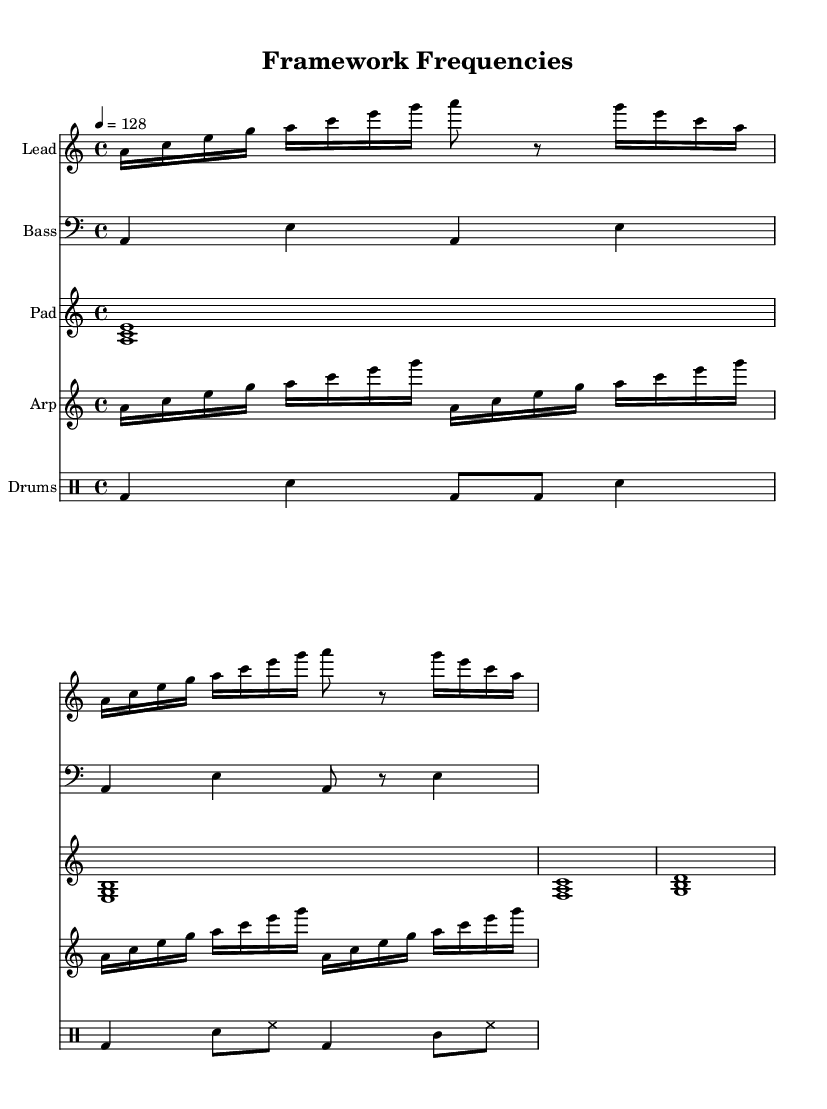What is the key signature of this music? The key signature is specified at the beginning of the global definitions section. It indicates that the piece is in A minor, which has no sharps or flats.
Answer: A minor What is the time signature of this track? The time signature is also set in the global definitions section of the code. It shows a 4/4 time signature, which is common in house music for its steady rhythm.
Answer: 4/4 What is the tempo of the piece? The tempo is defined in the global section, with a speed of 128 beats per minute, typical for progressive house tracks that maintain an energetic pace.
Answer: 128 How many voices are present in the lead section? The lead section has a pattern that repeats many notes and includes distinct pitches. Analyzing the notes played together, there is mainly one voice in the lead synth.
Answer: 1 Which instrument plays the bass line? The instrument for the bass line is labeled in the score following its respective staff. It has a specific instrument name listed, which indicates that the bass synth is used.
Answer: Bass What type of rhythmic pattern is used in the percussion section? The percussion section is represented under the drum staff, showing specific patterns for bass and snare drums. On observing, the rhythmic pattern primarily uses a combination of quarter notes and eighth notes.
Answer: 4/4 pattern Are there any layered synths present in this piece? The code defines several different synth parts (lead, bass, pad, and arpeggiator) that interact throughout the piece, creating a rich, layered sound typical of progressive house music.
Answer: Yes 